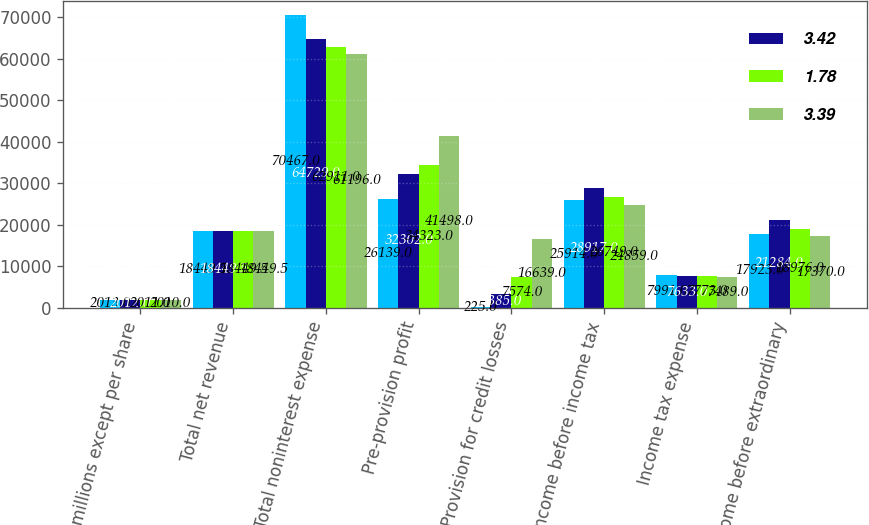Convert chart to OTSL. <chart><loc_0><loc_0><loc_500><loc_500><stacked_bar_chart><ecel><fcel>(in millions except per share<fcel>Total net revenue<fcel>Total noninterest expense<fcel>Pre-provision profit<fcel>Provision for credit losses<fcel>Income before income tax<fcel>Income tax expense<fcel>Income before extraordinary<nl><fcel>nan<fcel>2013<fcel>18449.5<fcel>70467<fcel>26139<fcel>225<fcel>25914<fcel>7991<fcel>17923<nl><fcel>3.42<fcel>2012<fcel>18449.5<fcel>64729<fcel>32302<fcel>3385<fcel>28917<fcel>7633<fcel>21284<nl><fcel>1.78<fcel>2011<fcel>18449.5<fcel>62911<fcel>34323<fcel>7574<fcel>26749<fcel>7773<fcel>18976<nl><fcel>3.39<fcel>2010<fcel>18449.5<fcel>61196<fcel>41498<fcel>16639<fcel>24859<fcel>7489<fcel>17370<nl></chart> 